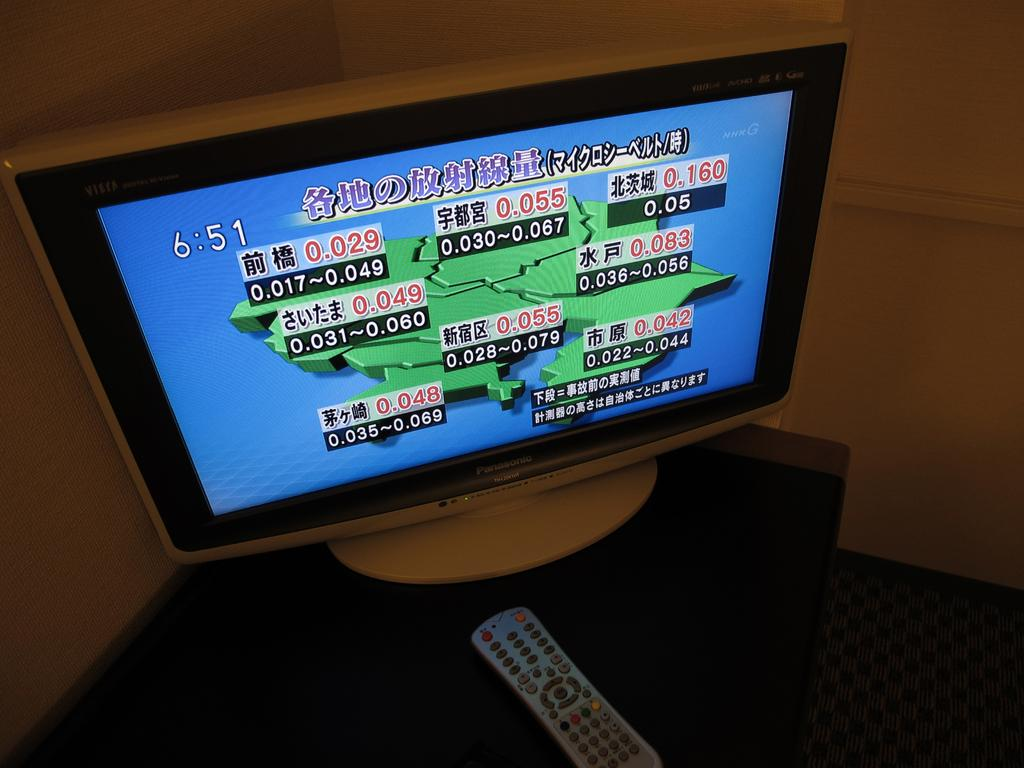What electronic device is present in the image? There is a television in the image. What object is on the table near the television? There is a remote on the table in the image. What type of flooring is visible in the image? There is a carpet in the image. What can be seen in the background of the image? There is a wall in the background of the image. What type of shop can be seen in the image? There is no shop present in the image; it features a television, a remote, a carpet, and a wall. What type of soda is being advertised on the television in the image? There is no soda being advertised on the television in the image, as the content of the television program or advertisement is not visible. 